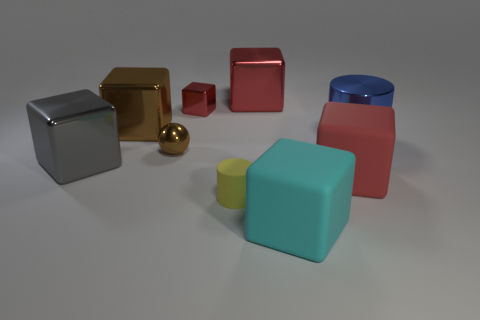There is a big block that is the same color as the sphere; what is its material?
Ensure brevity in your answer.  Metal. There is a large shiny block on the right side of the tiny brown metal thing; is its color the same as the small thing that is behind the brown shiny cube?
Provide a succinct answer. Yes. There is a big matte thing behind the small yellow matte object; does it have the same color as the tiny block?
Provide a succinct answer. Yes. What is the size of the metallic block that is the same color as the small metallic ball?
Give a very brief answer. Large. The thing that is the same color as the sphere is what shape?
Your answer should be compact. Cube. The big red object that is made of the same material as the yellow cylinder is what shape?
Provide a succinct answer. Cube. Is there anything else that has the same color as the big cylinder?
Provide a succinct answer. No. Is the color of the small rubber object the same as the large thing that is in front of the red rubber cube?
Give a very brief answer. No. Is the number of matte blocks behind the gray cube less than the number of large gray objects?
Make the answer very short. Yes. What is the material of the brown thing behind the tiny brown metal ball?
Your answer should be very brief. Metal. 